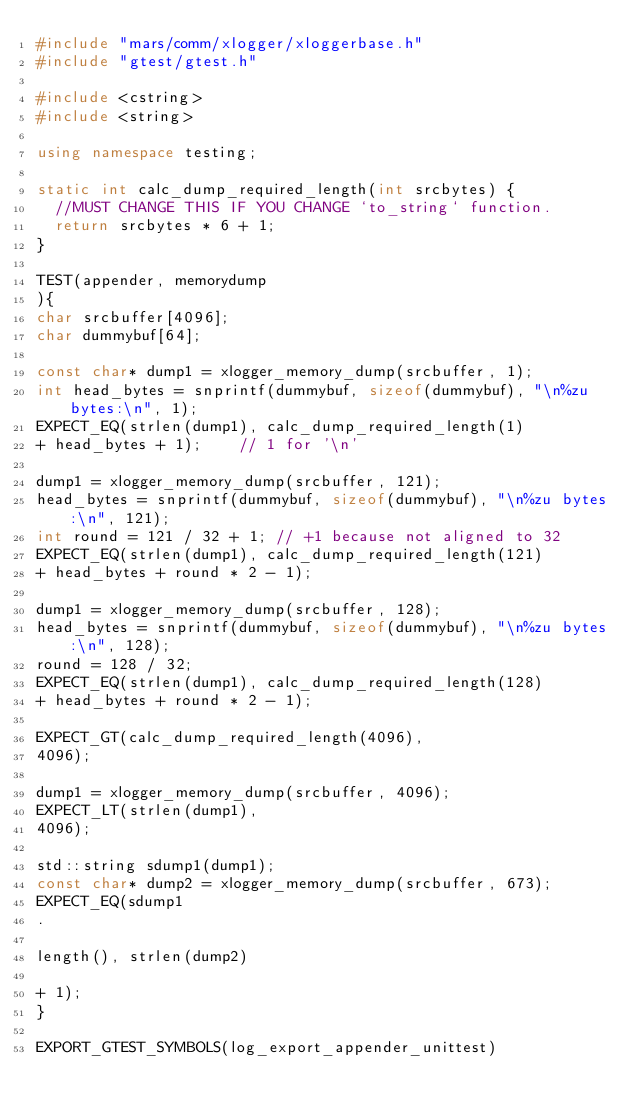<code> <loc_0><loc_0><loc_500><loc_500><_C++_>#include "mars/comm/xlogger/xloggerbase.h"
#include "gtest/gtest.h"

#include <cstring>
#include <string>

using namespace testing;

static int calc_dump_required_length(int srcbytes) {
  //MUST CHANGE THIS IF YOU CHANGE `to_string` function.
  return srcbytes * 6 + 1;
}

TEST(appender, memorydump
){
char srcbuffer[4096];
char dummybuf[64];

const char* dump1 = xlogger_memory_dump(srcbuffer, 1);
int head_bytes = snprintf(dummybuf, sizeof(dummybuf), "\n%zu bytes:\n", 1);
EXPECT_EQ(strlen(dump1), calc_dump_required_length(1)
+ head_bytes + 1);    // 1 for '\n'

dump1 = xlogger_memory_dump(srcbuffer, 121);
head_bytes = snprintf(dummybuf, sizeof(dummybuf), "\n%zu bytes:\n", 121);
int round = 121 / 32 + 1; // +1 because not aligned to 32
EXPECT_EQ(strlen(dump1), calc_dump_required_length(121)
+ head_bytes + round * 2 - 1);

dump1 = xlogger_memory_dump(srcbuffer, 128);
head_bytes = snprintf(dummybuf, sizeof(dummybuf), "\n%zu bytes:\n", 128);
round = 128 / 32;
EXPECT_EQ(strlen(dump1), calc_dump_required_length(128)
+ head_bytes + round * 2 - 1);

EXPECT_GT(calc_dump_required_length(4096),
4096);

dump1 = xlogger_memory_dump(srcbuffer, 4096);
EXPECT_LT(strlen(dump1),
4096);

std::string sdump1(dump1);
const char* dump2 = xlogger_memory_dump(srcbuffer, 673);
EXPECT_EQ(sdump1
.

length(), strlen(dump2)

+ 1);
}

EXPORT_GTEST_SYMBOLS(log_export_appender_unittest)

</code> 